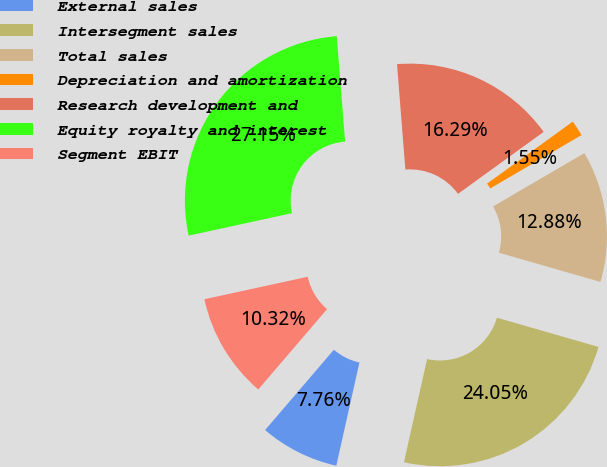Convert chart. <chart><loc_0><loc_0><loc_500><loc_500><pie_chart><fcel>External sales<fcel>Intersegment sales<fcel>Total sales<fcel>Depreciation and amortization<fcel>Research development and<fcel>Equity royalty and interest<fcel>Segment EBIT<nl><fcel>7.76%<fcel>24.05%<fcel>12.88%<fcel>1.55%<fcel>16.29%<fcel>27.15%<fcel>10.32%<nl></chart> 